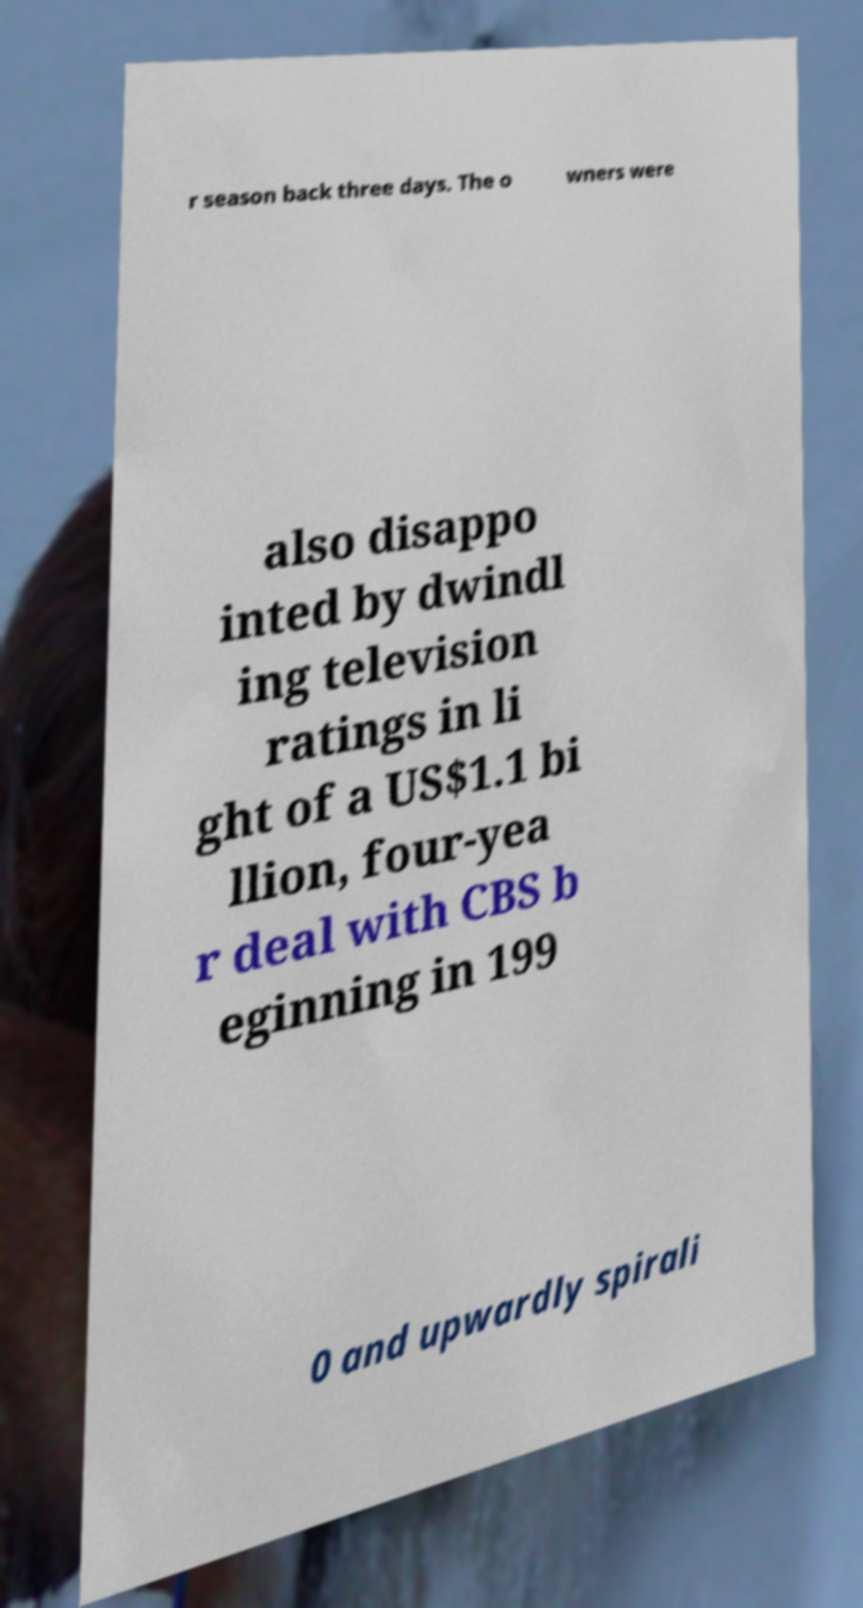Could you extract and type out the text from this image? r season back three days. The o wners were also disappo inted by dwindl ing television ratings in li ght of a US$1.1 bi llion, four-yea r deal with CBS b eginning in 199 0 and upwardly spirali 